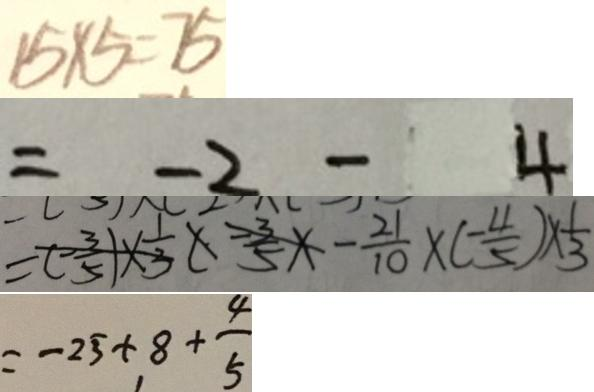<formula> <loc_0><loc_0><loc_500><loc_500>1 5 \times 5 = 7 5 
 = - 2 - 4 
 = ( - \frac { 3 } { 5 } ) \times \frac { 1 } { 3 } ( - \frac { 3 } { 5 } \times - \frac { 2 1 } { 1 0 } \times ( - \frac { 4 } { 5 } ) \times \frac { 1 } { 3 } 
 = - 2 5 + 8 + \frac { 4 } { 5 }</formula> 